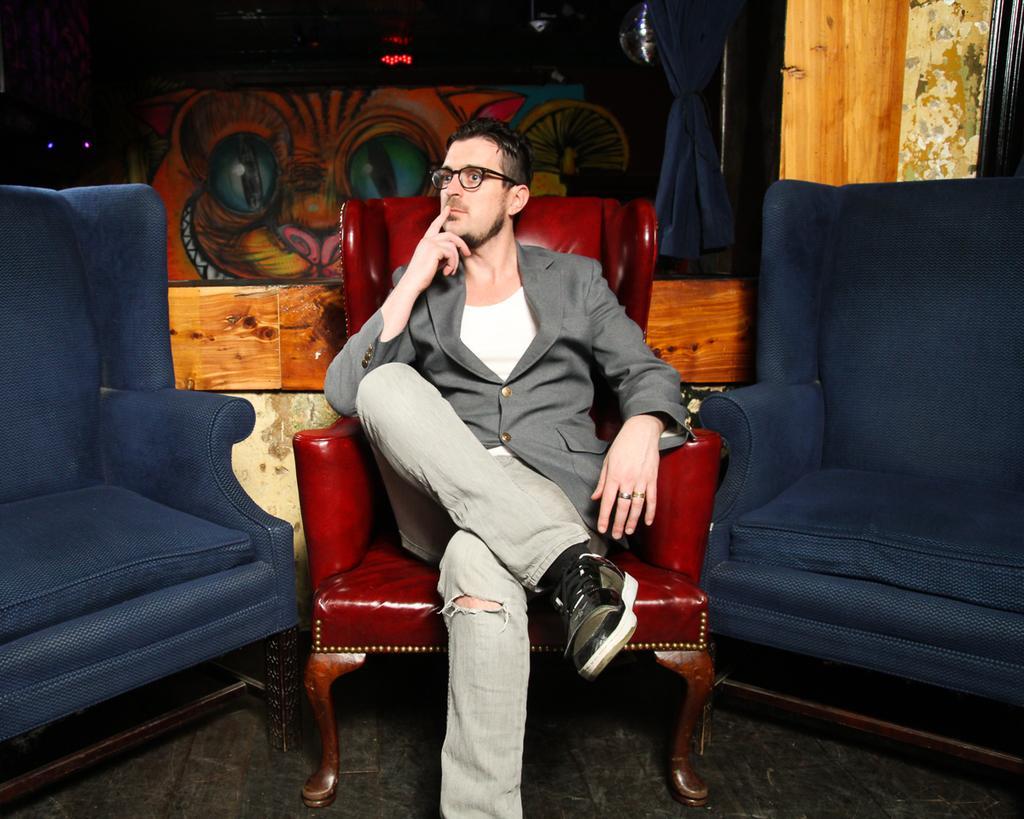Describe this image in one or two sentences. In this picture there is a man sitting on the sofa in the middle, the sofa is in red in color. Besides him there are two sofas which are in blue. He is wearing a grey blazer, cream trousers and black shoes. In the background there are some trunks. 